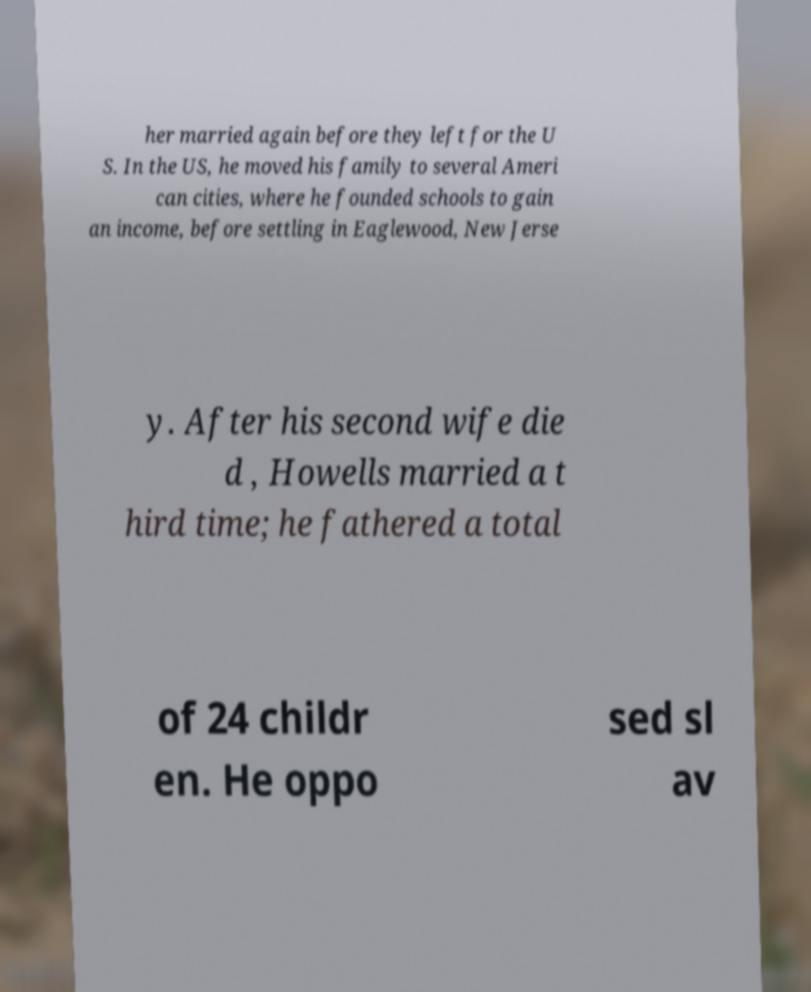For documentation purposes, I need the text within this image transcribed. Could you provide that? her married again before they left for the U S. In the US, he moved his family to several Ameri can cities, where he founded schools to gain an income, before settling in Eaglewood, New Jerse y. After his second wife die d , Howells married a t hird time; he fathered a total of 24 childr en. He oppo sed sl av 